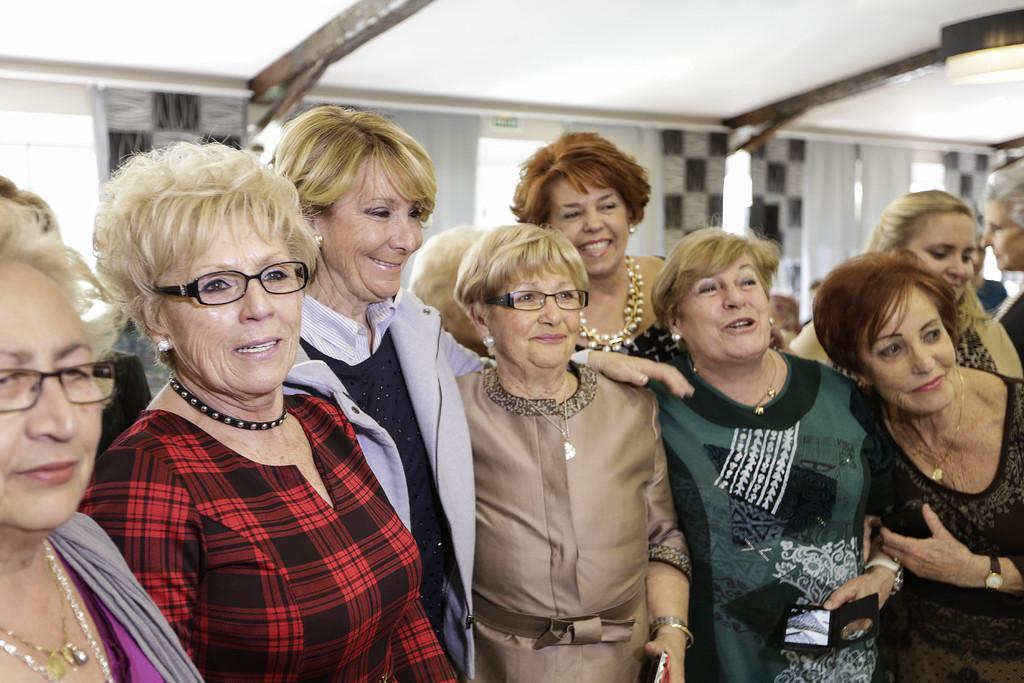Describe this image in one or two sentences. In this image there are group of women standing, they are holding an object, there are windows, there are curtains, there is the roof towards the top of the image, there is a light towards the right of the image. 